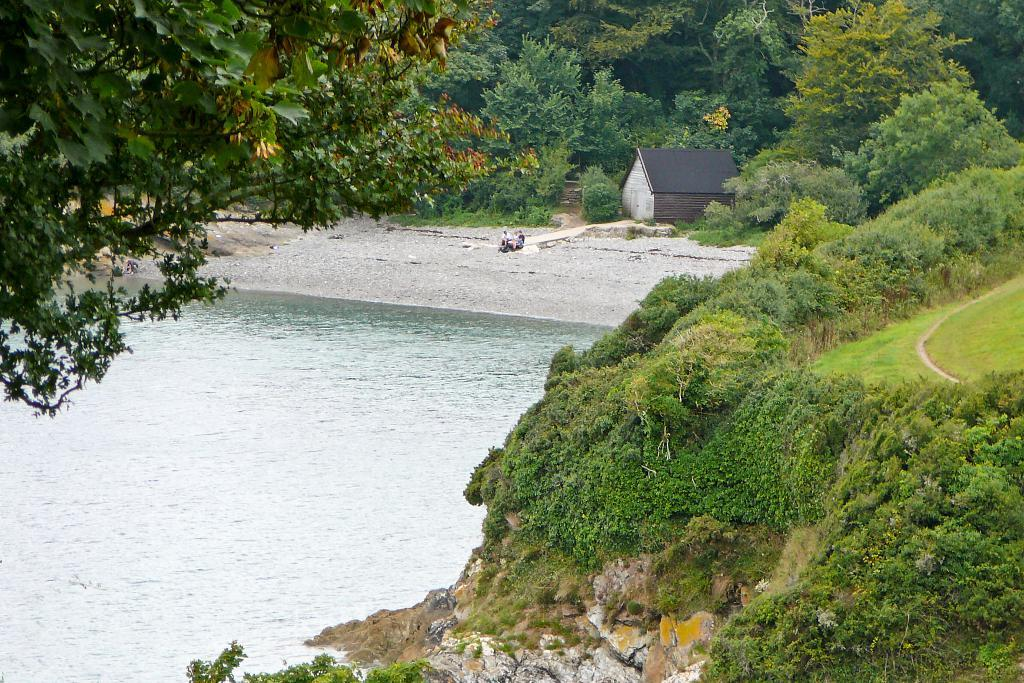What can be seen on the left side of the image? There is water on the left side of the image. What type of vegetation or plants can be observed in the image? There is greenery around the area of the image. What type of structure is located at the top side of the image? There is a shed at the top side of the image. Can you see a family flying a kite in the image? There is no family or kite present in the image. What type of flight is taking place in the image? There is no flight or any reference to flying in the image. 